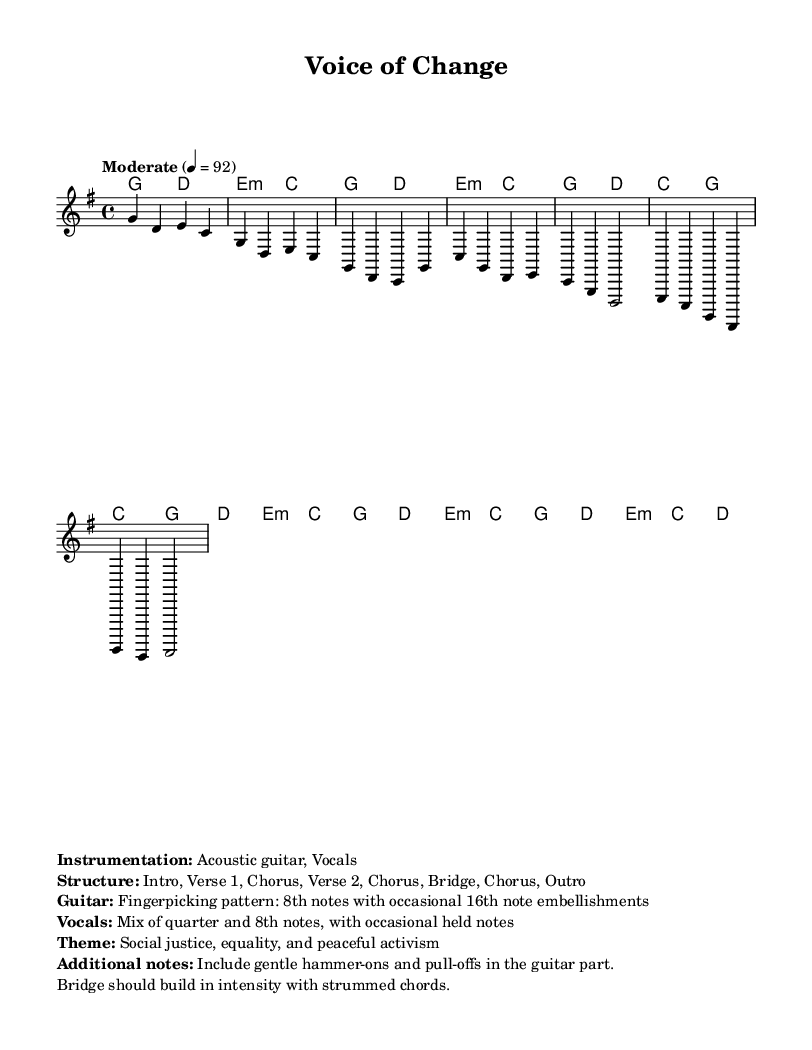What is the key signature of this music? The key signature is G major, which has one sharp (F#).
Answer: G major What is the time signature of this piece? The time signature is 4/4, which means there are four beats in each measure and a quarter note gets one beat.
Answer: 4/4 What is the tempo marking in the score? The tempo marking indicates "Moderate" with a metronome mark of 92 beats per minute, suggesting a moderate pace for the performance.
Answer: Moderate 4 = 92 What are the primary themes expressed in the song? The primary themes are social justice, equality, and peaceful activism, as indicated in the title and additional notes.
Answer: Social justice, equality, and peaceful activism How would the guitar part be characterized based on the additional notes? The guitar part is characterized by a fingerpicking pattern that consists of 8th notes with some occasional 16th note embellishments, creating a gentle, flowing sound typical of folk music.
Answer: Fingerpicking pattern with 8th notes What is the structure of the song? The structure includes an Intro, Verse 1, Chorus, Verse 2, Chorus, Bridge, Chorus, and Outro, showing a clear organization typical for folk songs that convey storytelling.
Answer: Intro, Verse 1, Chorus, Verse 2, Chorus, Bridge, Chorus, Outro How does the intensity change in the bridge section? The intensity builds during the bridge section with strummed chords, creating a contrast to the earlier sections that have more gentle fingerpicking, enhancing the emotional impact of the song.
Answer: Builds in intensity 